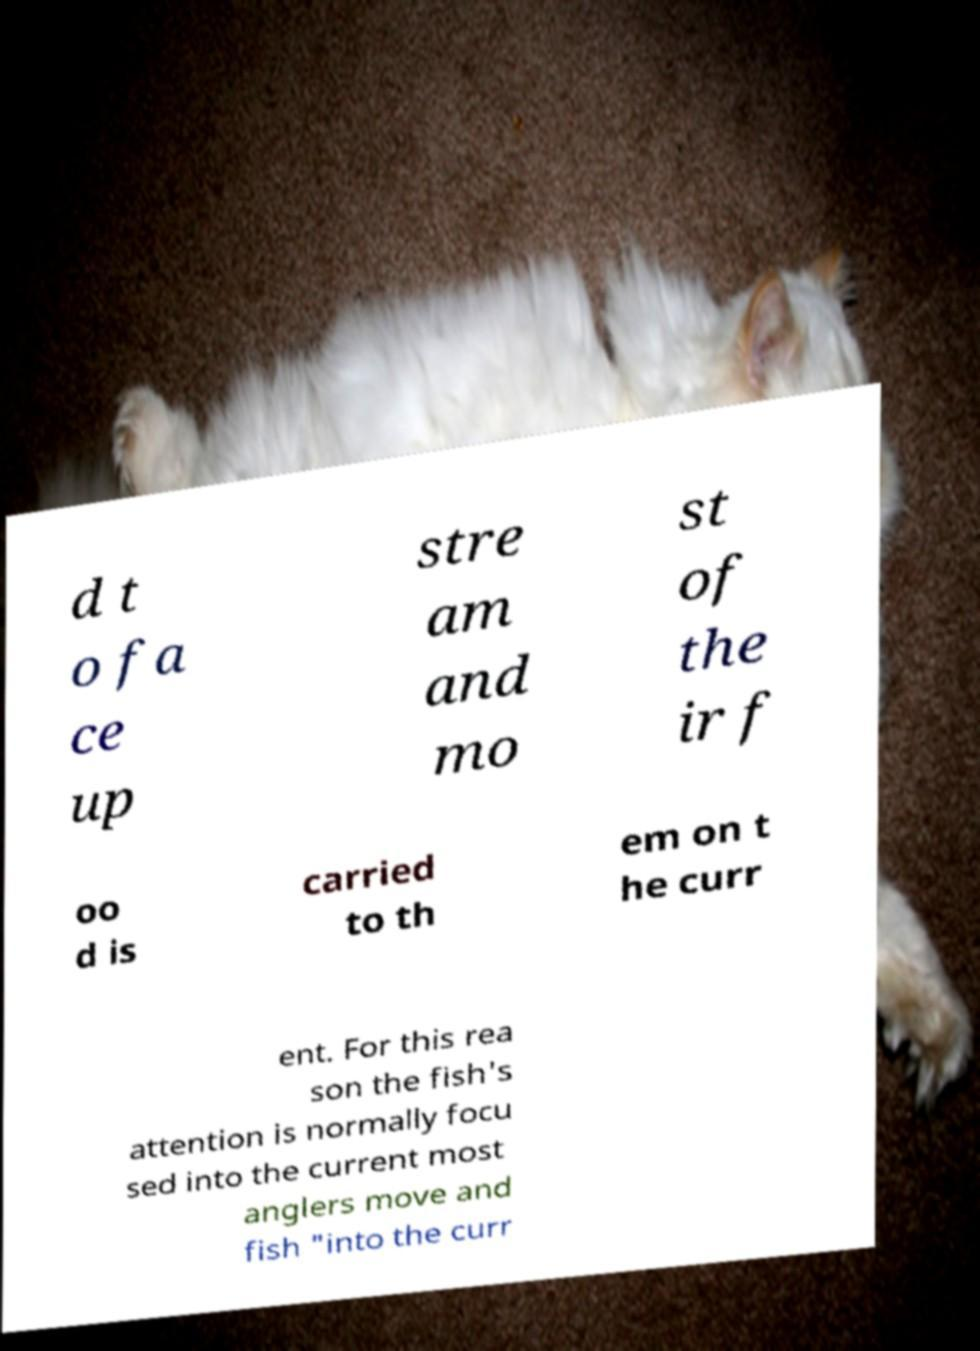Can you accurately transcribe the text from the provided image for me? d t o fa ce up stre am and mo st of the ir f oo d is carried to th em on t he curr ent. For this rea son the fish's attention is normally focu sed into the current most anglers move and fish "into the curr 